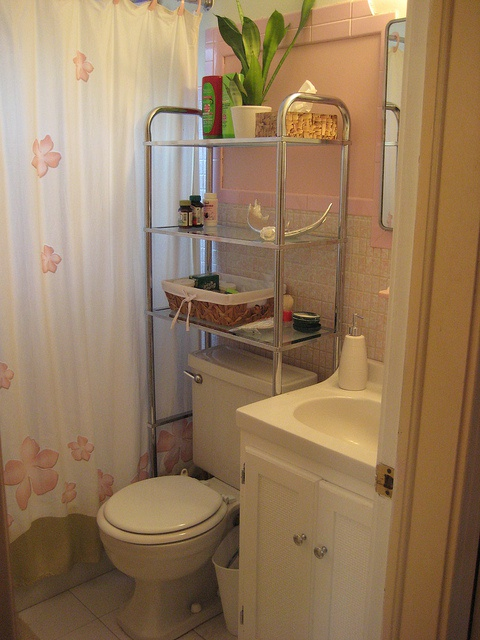Describe the objects in this image and their specific colors. I can see toilet in tan and gray tones, potted plant in tan, olive, and gray tones, sink in tan tones, bottle in tan, gray, and olive tones, and bottle in tan, gray, brown, and maroon tones in this image. 